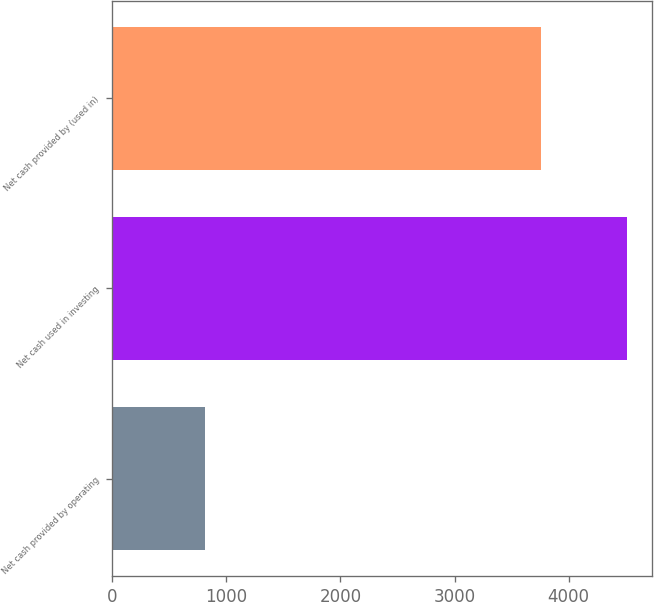Convert chart. <chart><loc_0><loc_0><loc_500><loc_500><bar_chart><fcel>Net cash provided by operating<fcel>Net cash used in investing<fcel>Net cash provided by (used in)<nl><fcel>815.3<fcel>4508.3<fcel>3756<nl></chart> 